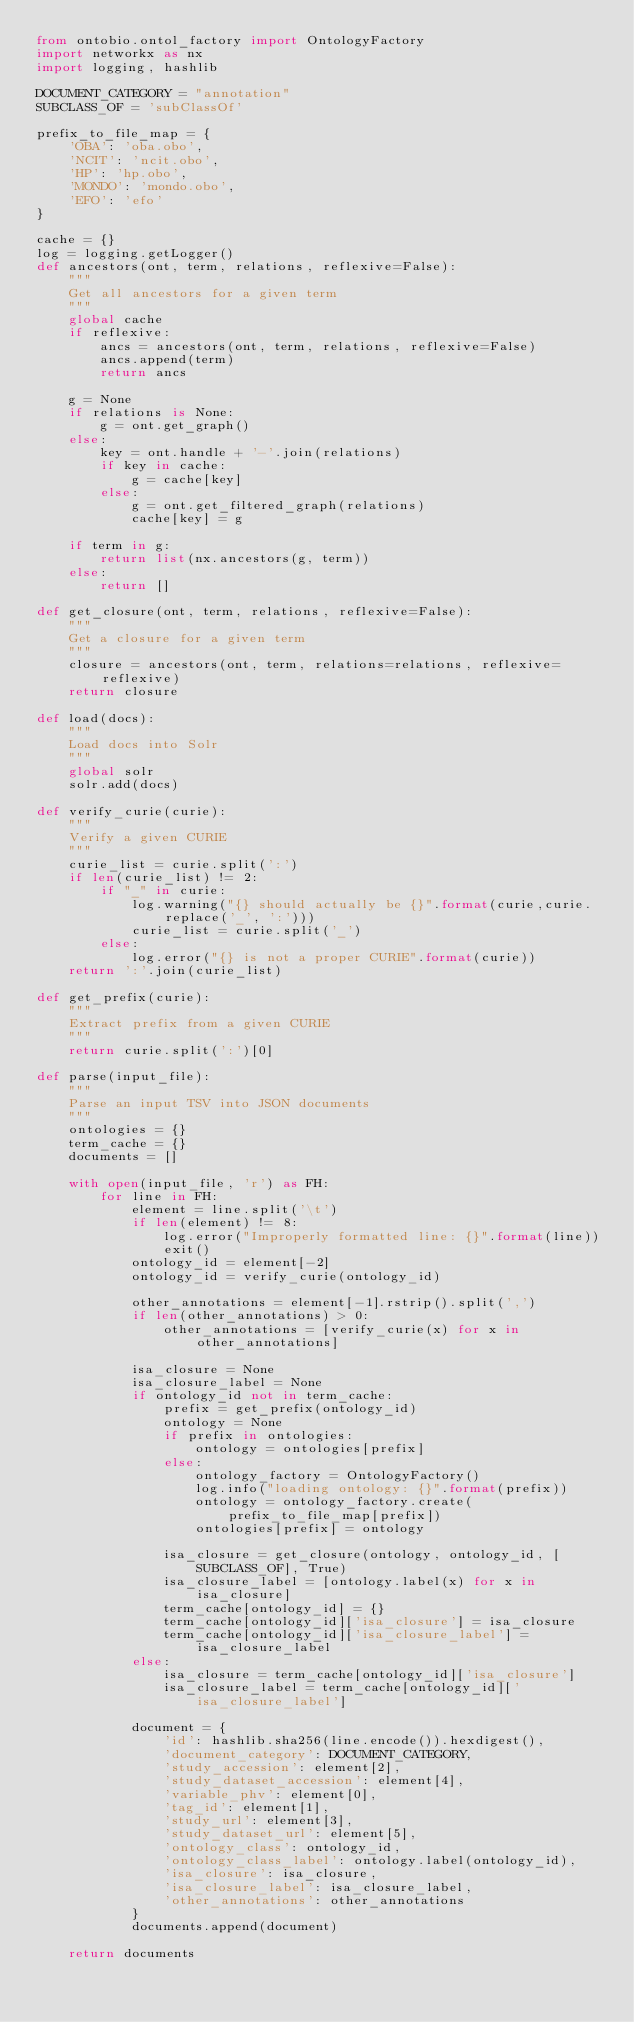<code> <loc_0><loc_0><loc_500><loc_500><_Python_>from ontobio.ontol_factory import OntologyFactory
import networkx as nx
import logging, hashlib

DOCUMENT_CATEGORY = "annotation"
SUBCLASS_OF = 'subClassOf'

prefix_to_file_map = {
    'OBA': 'oba.obo',
    'NCIT': 'ncit.obo',
    'HP': 'hp.obo',
    'MONDO': 'mondo.obo',
    'EFO': 'efo'
}

cache = {}
log = logging.getLogger()
def ancestors(ont, term, relations, reflexive=False):
    """
    Get all ancestors for a given term
    """
    global cache
    if reflexive:
        ancs = ancestors(ont, term, relations, reflexive=False)
        ancs.append(term)
        return ancs

    g = None
    if relations is None:
        g = ont.get_graph()
    else:
        key = ont.handle + '-'.join(relations)
        if key in cache:
            g = cache[key]
        else:
            g = ont.get_filtered_graph(relations)
            cache[key] = g

    if term in g:
        return list(nx.ancestors(g, term))
    else:
        return []

def get_closure(ont, term, relations, reflexive=False):
    """
    Get a closure for a given term
    """
    closure = ancestors(ont, term, relations=relations, reflexive=reflexive)
    return closure

def load(docs):
    """
    Load docs into Solr
    """
    global solr
    solr.add(docs)

def verify_curie(curie):
    """
    Verify a given CURIE
    """
    curie_list = curie.split(':')
    if len(curie_list) != 2:
        if "_" in curie:
            log.warning("{} should actually be {}".format(curie,curie.replace('_', ':')))
            curie_list = curie.split('_')
        else:
            log.error("{} is not a proper CURIE".format(curie))
    return ':'.join(curie_list)

def get_prefix(curie):
    """
    Extract prefix from a given CURIE
    """
    return curie.split(':')[0]

def parse(input_file):
    """
    Parse an input TSV into JSON documents
    """
    ontologies = {}
    term_cache = {}
    documents = []

    with open(input_file, 'r') as FH:
        for line in FH:
            element = line.split('\t')
            if len(element) != 8:
                log.error("Improperly formatted line: {}".format(line))
                exit()
            ontology_id = element[-2]
            ontology_id = verify_curie(ontology_id)

            other_annotations = element[-1].rstrip().split(',')
            if len(other_annotations) > 0:
                other_annotations = [verify_curie(x) for x in other_annotations]

            isa_closure = None
            isa_closure_label = None
            if ontology_id not in term_cache:
                prefix = get_prefix(ontology_id)
                ontology = None
                if prefix in ontologies:
                    ontology = ontologies[prefix]
                else:
                    ontology_factory = OntologyFactory()
                    log.info("loading ontology: {}".format(prefix))
                    ontology = ontology_factory.create(prefix_to_file_map[prefix])
                    ontologies[prefix] = ontology

                isa_closure = get_closure(ontology, ontology_id, [SUBCLASS_OF], True)
                isa_closure_label = [ontology.label(x) for x in isa_closure]
                term_cache[ontology_id] = {}
                term_cache[ontology_id]['isa_closure'] = isa_closure
                term_cache[ontology_id]['isa_closure_label'] = isa_closure_label
            else:
                isa_closure = term_cache[ontology_id]['isa_closure']
                isa_closure_label = term_cache[ontology_id]['isa_closure_label']

            document = {
                'id': hashlib.sha256(line.encode()).hexdigest(),
                'document_category': DOCUMENT_CATEGORY,
                'study_accession': element[2],
                'study_dataset_accession': element[4],
                'variable_phv': element[0],
                'tag_id': element[1],
                'study_url': element[3],
                'study_dataset_url': element[5],
                'ontology_class': ontology_id,
                'ontology_class_label': ontology.label(ontology_id),
                'isa_closure': isa_closure,
                'isa_closure_label': isa_closure_label,
                'other_annotations': other_annotations
            }
            documents.append(document)

    return documents
</code> 